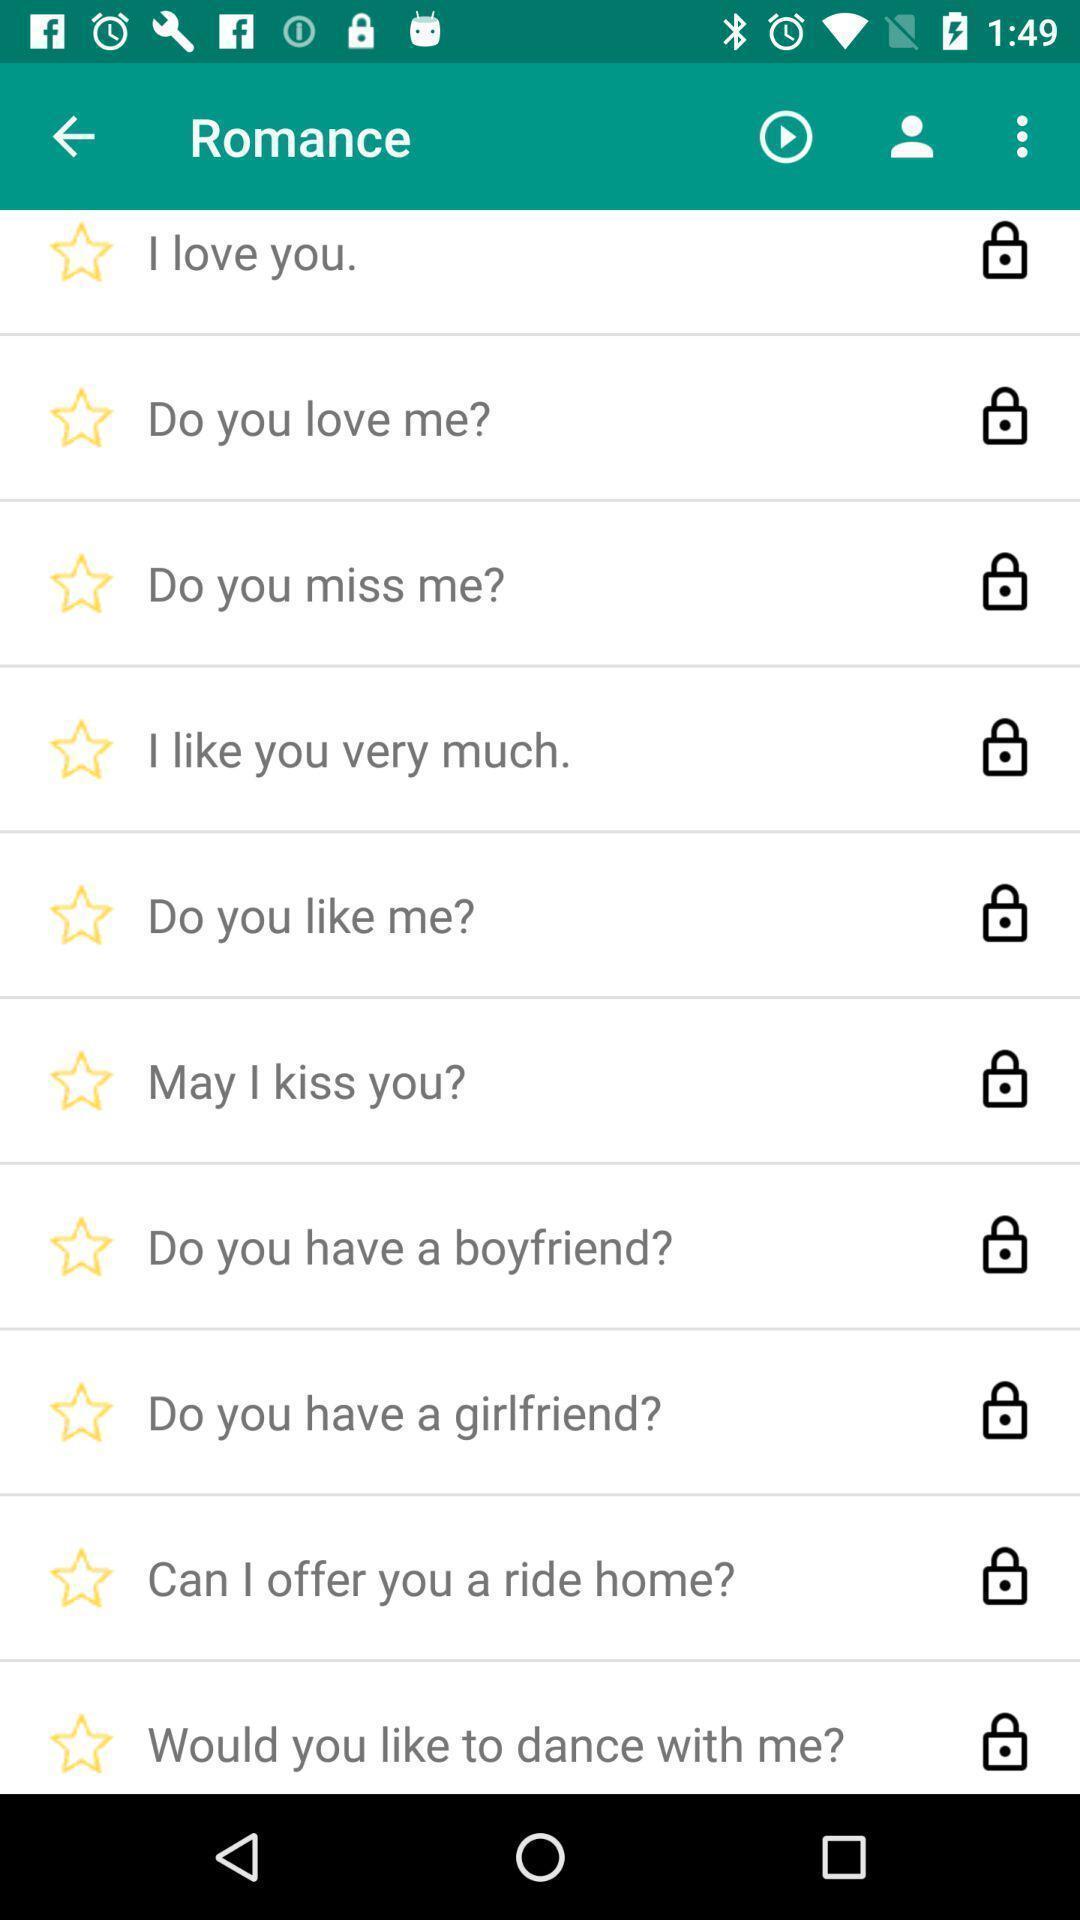Describe the key features of this screenshot. Page showing multiple options. 